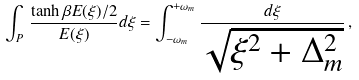Convert formula to latex. <formula><loc_0><loc_0><loc_500><loc_500>\int _ { P } \, { \frac { \tanh \beta E ( \xi ) / 2 } { E ( \xi ) } } d \xi = \int _ { - \omega _ { m } } ^ { + \omega _ { m } } { \frac { d \xi } { \sqrt { \xi ^ { 2 } + \Delta _ { m } ^ { 2 } } } } \, ,</formula> 